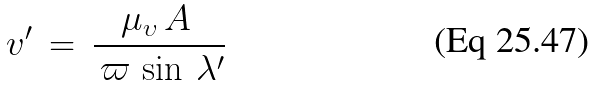Convert formula to latex. <formula><loc_0><loc_0><loc_500><loc_500>v ^ { \prime } \, = \, \frac { \mu _ { \upsilon } \, A \, } { \, \varpi \, \sin \, \lambda ^ { \prime } }</formula> 